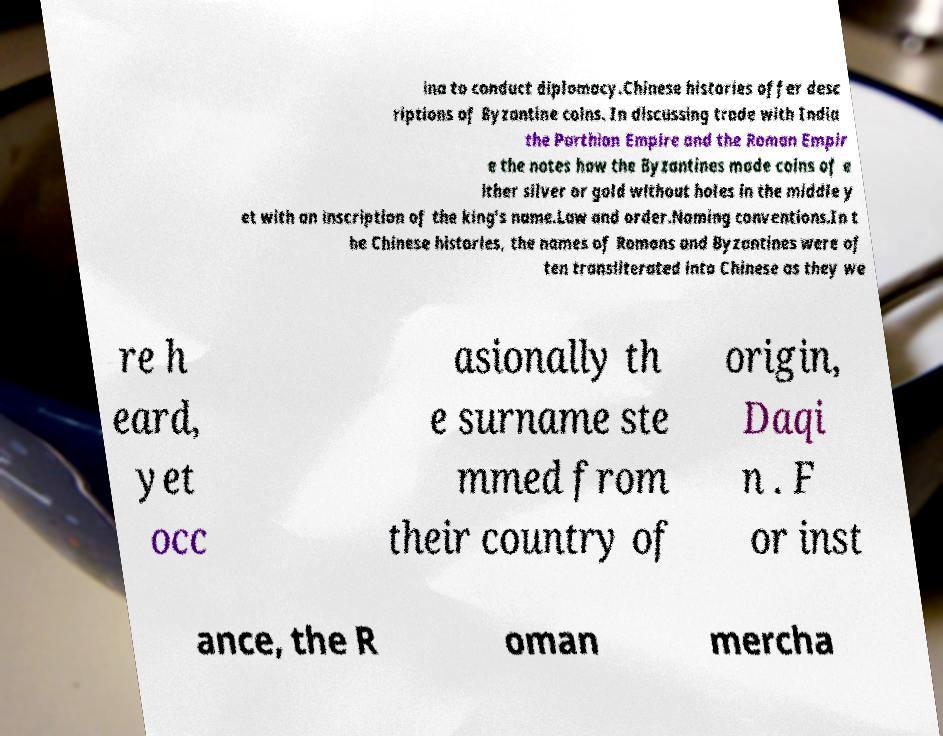I need the written content from this picture converted into text. Can you do that? ina to conduct diplomacy.Chinese histories offer desc riptions of Byzantine coins. In discussing trade with India the Parthian Empire and the Roman Empir e the notes how the Byzantines made coins of e ither silver or gold without holes in the middle y et with an inscription of the king's name.Law and order.Naming conventions.In t he Chinese histories, the names of Romans and Byzantines were of ten transliterated into Chinese as they we re h eard, yet occ asionally th e surname ste mmed from their country of origin, Daqi n . F or inst ance, the R oman mercha 